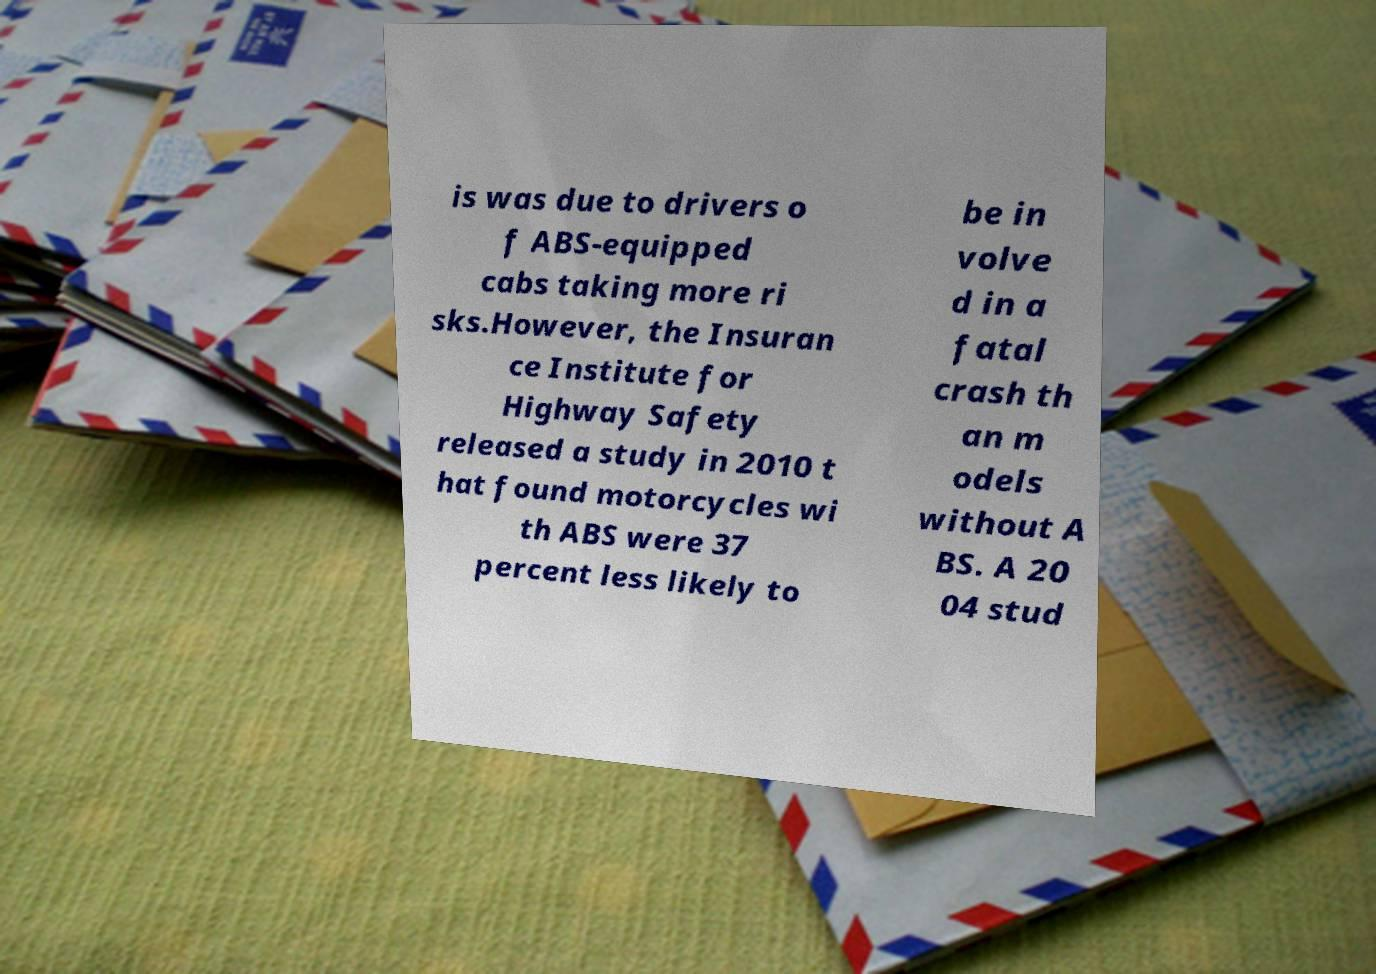Please identify and transcribe the text found in this image. is was due to drivers o f ABS-equipped cabs taking more ri sks.However, the Insuran ce Institute for Highway Safety released a study in 2010 t hat found motorcycles wi th ABS were 37 percent less likely to be in volve d in a fatal crash th an m odels without A BS. A 20 04 stud 